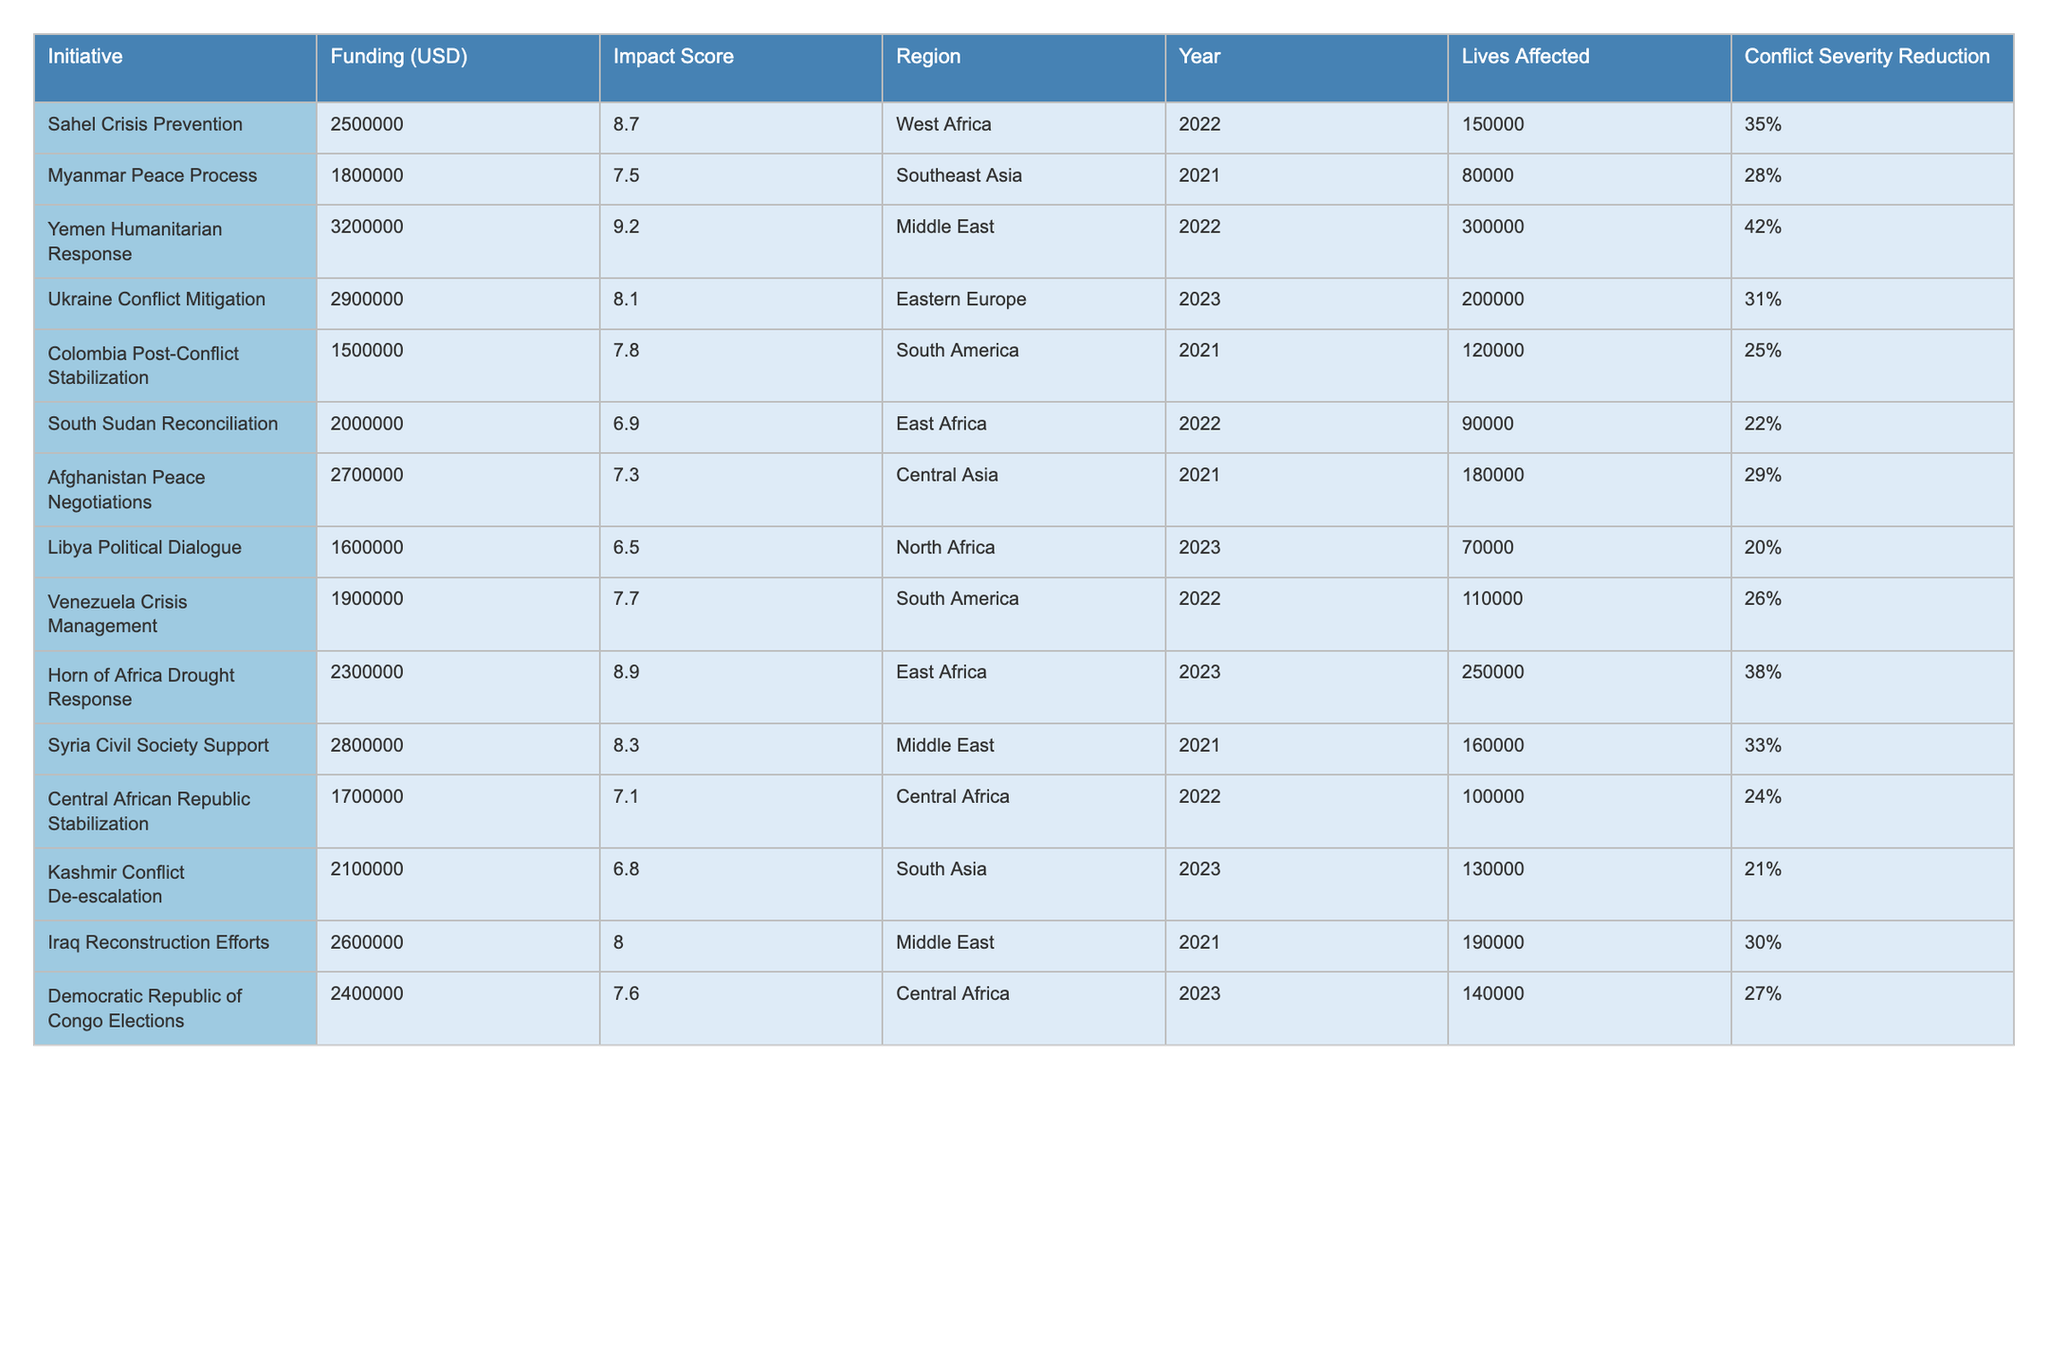What is the funding amount for the Yemen Humanitarian Response initiative? The table lists the funding amount for the Yemen Humanitarian Response initiative under the "Funding (USD)" column. The value provided is 3,200,000.
Answer: 3,200,000 Which initiative has the highest impact score and what is that score? By checking the "Impact Score" column in the table, the Yemen Humanitarian Response has the highest score listed as 9.2.
Answer: 9.2 Calculate the total funding allocated to initiatives in East Africa. The initiatives in East Africa are South Sudan Reconciliation (2,000,000) and Horn of Africa Drought Response (2,300,000). Adding these amounts gives a total of 2,000,000 + 2,300,000 = 4,300,000.
Answer: 4,300,000 Is the funding for the Libya Political Dialogue initiative more than the funding for the Kashmir Conflict De-escalation initiative? The funding for Libya Political Dialogue is 1,600,000, and for Kashmir Conflict De-escalation, it is 2,100,000. Since 1,600,000 is less than 2,100,000, the statement is false.
Answer: No What is the average impact score for all initiatives in South America? The initiatives in South America are Colombia Post-Conflict Stabilization (7.8) and Venezuela Crisis Management (7.7). To find the average, add the scores (7.8 + 7.7 = 15.5) and then divide by the number of initiatives (2), which gives 15.5 / 2 = 7.75.
Answer: 7.75 Which region has the initiative with the highest lives affected and what is that number? The initiative with the highest lives affected is the Yemen Humanitarian Response, which is in the Middle East, affecting 300,000 lives.
Answer: Middle East, 300,000 If you combine the funding for the Ukraine Conflict Mitigation and Yemen Humanitarian Response initiatives, what is the total funding? The funding amounts are 2,900,000 for Ukraine Conflict Mitigation and 3,200,000 for Yemen Humanitarian Response. Adding these gives a total of 2,900,000 + 3,200,000 = 6,100,000.
Answer: 6,100,000 Does the initiative with the lowest conflict severity reduction have a lower impact score than 7? The initiative with the lowest conflict severity reduction is Libya Political Dialogue, which has a severity reduction of 20% and an impact score of 6.5, which is indeed less than 7.
Answer: Yes What is the difference in impact score between the Sahel Crisis Prevention and Myanmar Peace Process initiatives? The impact score for Sahel Crisis Prevention is 8.7 and for Myanmar Peace Process is 7.5. The difference is 8.7 - 7.5 = 1.2.
Answer: 1.2 How many lives were affected by the initiatives in Southeast Asia? The only initiative in Southeast Asia is the Myanmar Peace Process, which affected 80,000 lives.
Answer: 80,000 